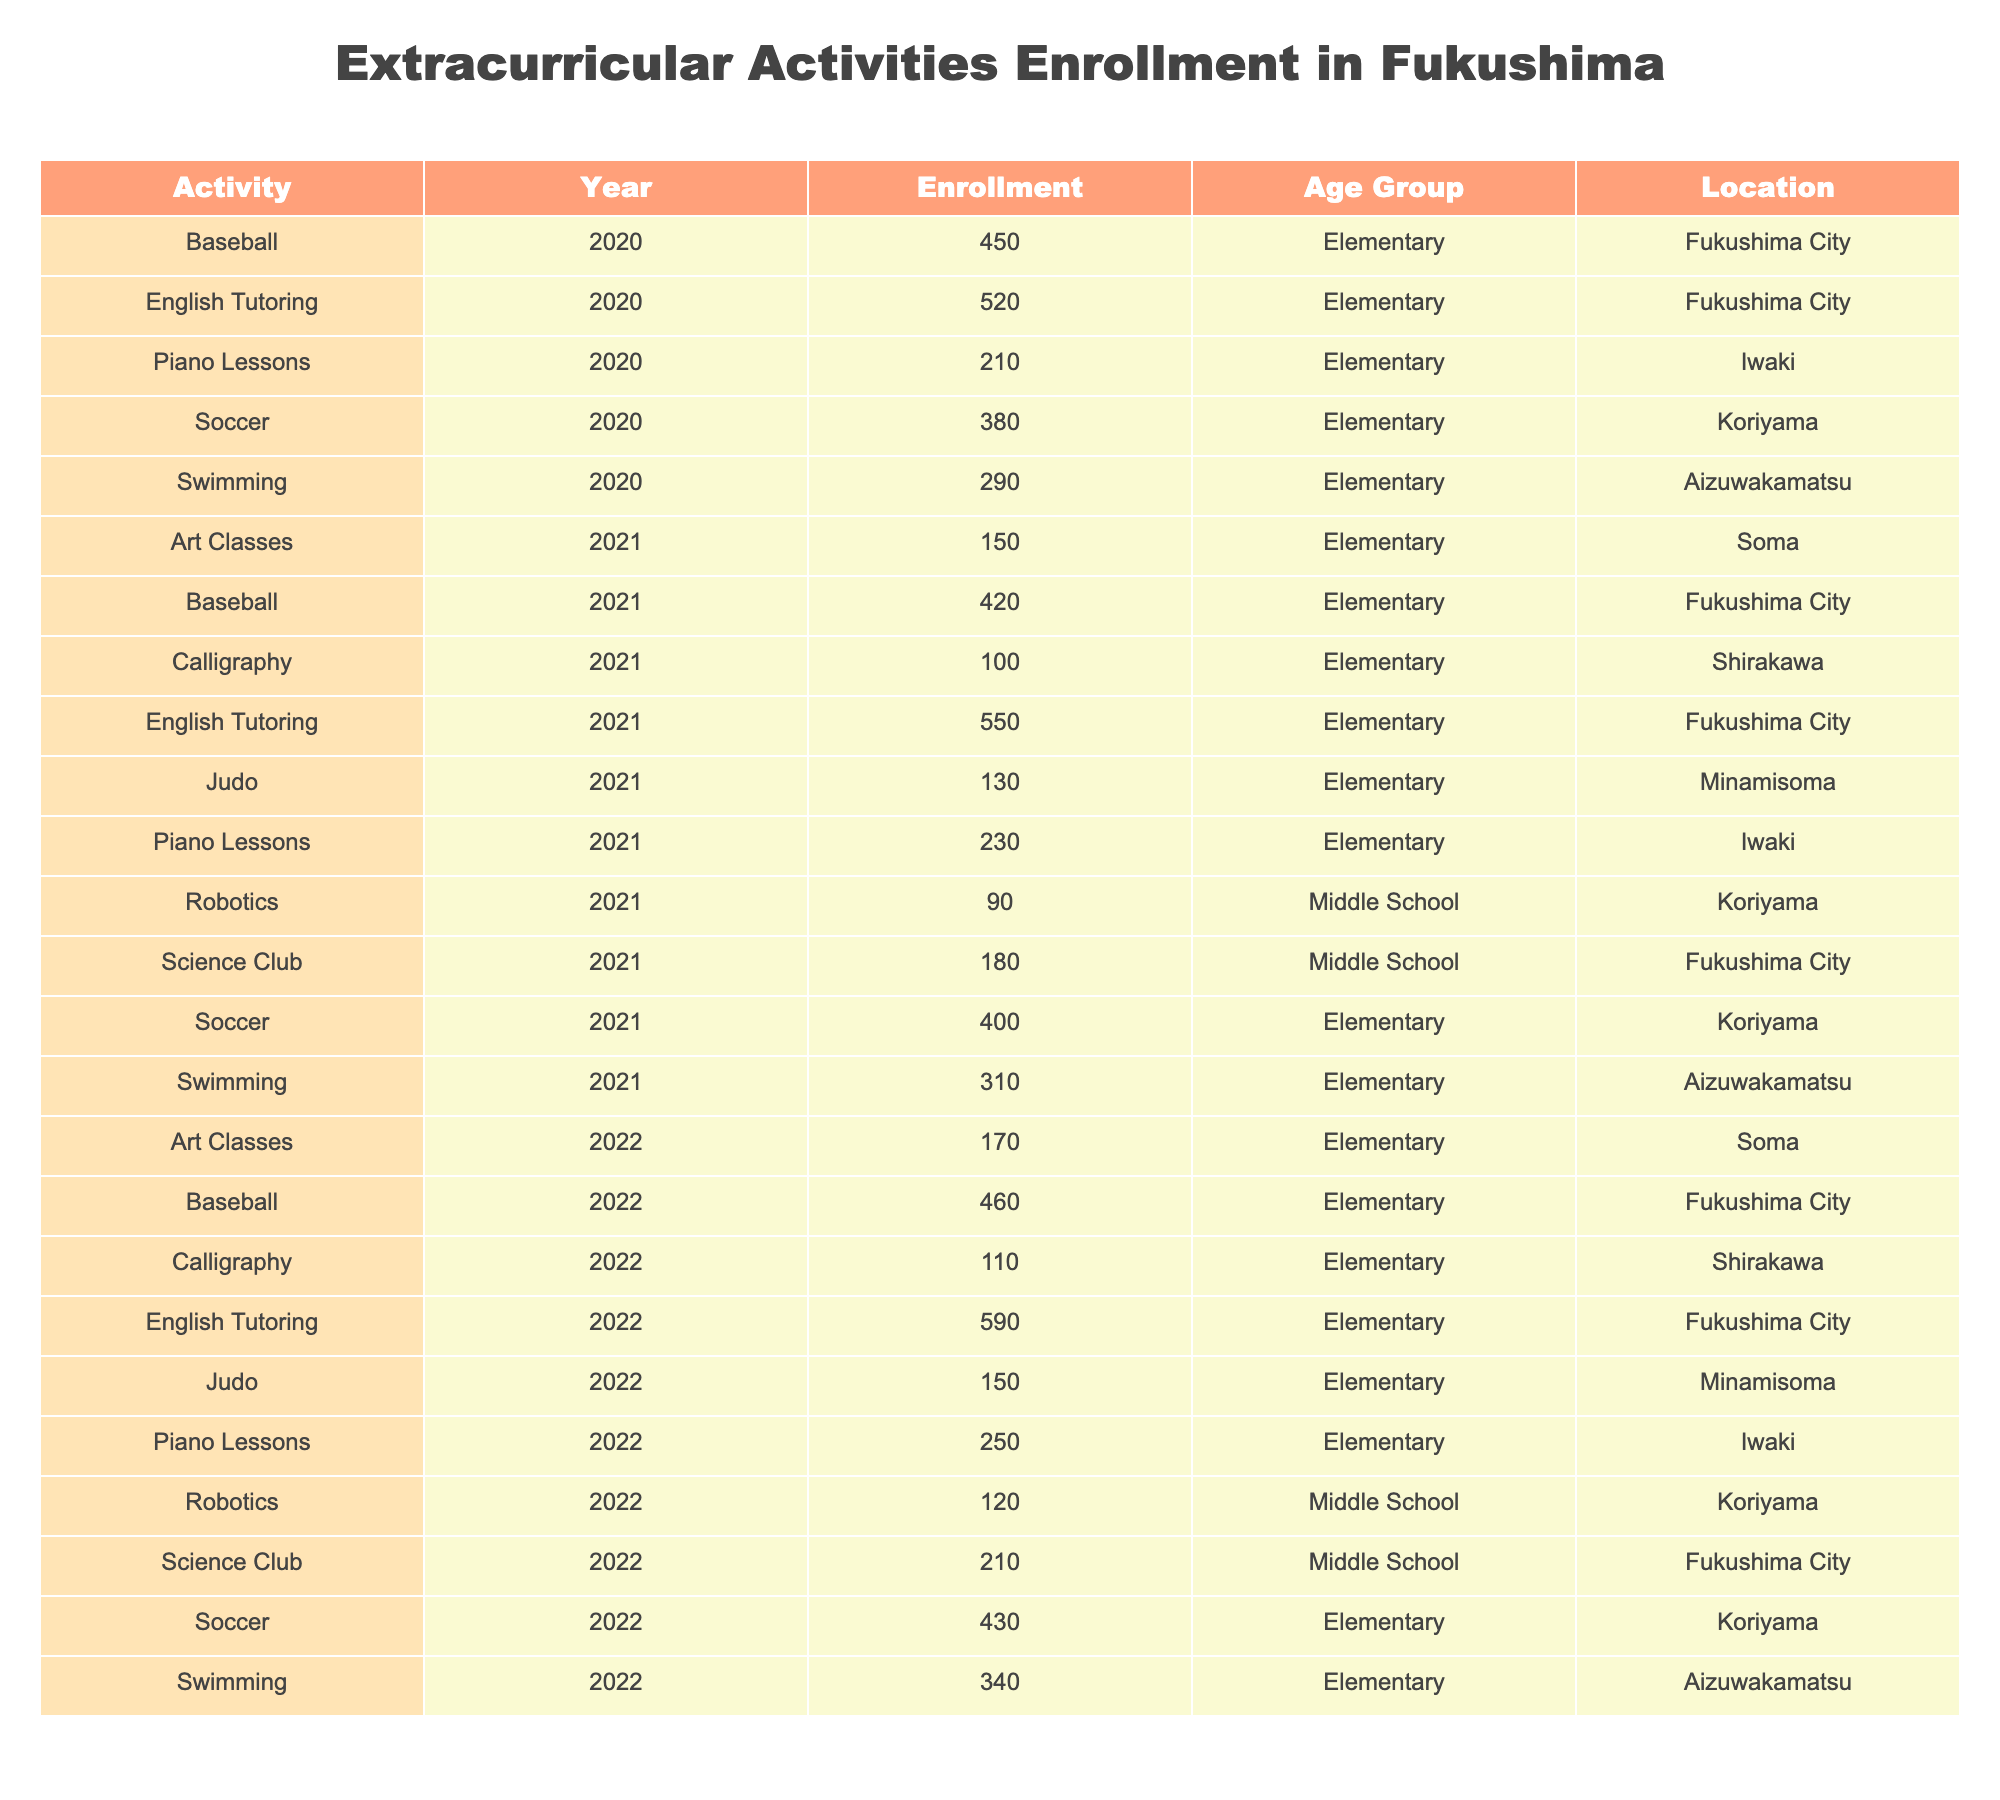What is the enrollment for English Tutoring in 2022? The table shows that the enrollment for English Tutoring in 2022 is listed under the relevant year and activity, which indicates a total of 590 students.
Answer: 590 Which extracurricular activity had the highest enrollment in 2021? By comparing the enrollment numbers across all activities in 2021, English Tutoring had the highest number at 550 students.
Answer: English Tutoring What is the total enrollment for Swimming activities from 2020 to 2022? We add the enrollments for Swimming across the three years: 290 (2020) + 310 (2021) + 340 (2022) = 940.
Answer: 940 Is the enrollment for Robotics in 2021 greater than in 2022? The table shows the enrollment for Robotics in 2021 is 90 and in 2022 it increased to 120, therefore the statement is false.
Answer: No What was the percentage increase in enrollment for Piano Lessons from 2021 to 2022? The enrollment increased from 230 in 2021 to 250 in 2022. To find the percentage increase: (250 - 230) / 230 * 100 = approximately 8.70%.
Answer: 8.70% In which location did Soccer have the highest enrollment in 2022? Looking at the table for Soccer enrollments in 2022, Koriyama has 430 enrollments, which is greater than any other locations listed for Soccer that year.
Answer: Koriyama Considering only Elementary activities, what is the average enrollment for 2020? The relevant activities for 2020 are Baseball (450), Soccer (380), Piano Lessons (210), English Tutoring (520), Swimming (290), and Art Classes (included only if they're for Elementary). We sum them up: (450 + 380 + 210 + 520 + 290) = 1850. There are 5 activities, so the average is 1850 / 5 = 370.
Answer: 370 How many different activities are listed for Middle School students in 2022? The table lists Science Club, Robotics, and one Judo class for Middle School in 2022, giving a total of three activities.
Answer: 3 What is the trend in enrollment for Baseball from 2020 to 2022? The enrollments for Baseball are: 450 (2020), 420 (2021), and 460 (2022). It shows a decrease in 2021 followed by an increase in 2022, indicating variability in participation.
Answer: Fluctuating (decrease then increase) Is there any decrease in the enrollment for any extracurricular activity from 2021 to 2022? Comparing the enrollments, we see that Robotics decreased from 90 (2021) to 120 (2022) showing that there was no decrease in that case. However, Judo increased from 130 to 150, indicating no decrease for either.
Answer: No 